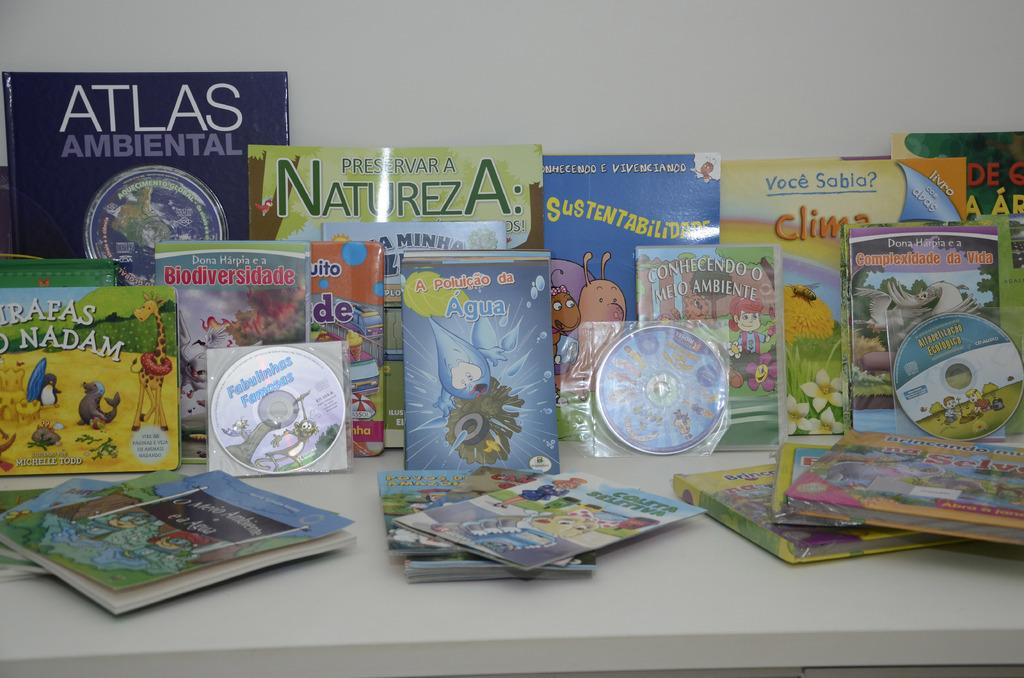What object can be seen in the image that is related to music or data storage? There is a CD in the image. What type of items are stored on the shelves in the image? There are books on shelves in the image. What can be seen in the background of the image? There is a wall visible in the background of the image. How many pies are stacked on top of the CD in the image? There are no pies present in the image; only a CD and books on shelves are visible. 